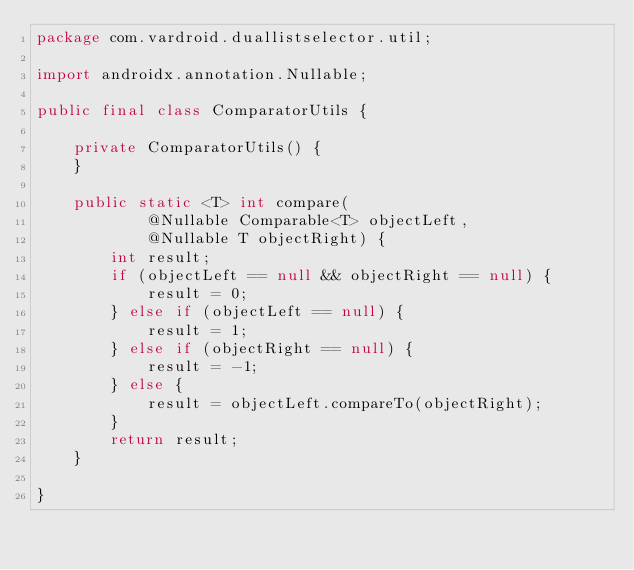<code> <loc_0><loc_0><loc_500><loc_500><_Java_>package com.vardroid.duallistselector.util;

import androidx.annotation.Nullable;

public final class ComparatorUtils {

    private ComparatorUtils() {
    }

    public static <T> int compare(
            @Nullable Comparable<T> objectLeft,
            @Nullable T objectRight) {
        int result;
        if (objectLeft == null && objectRight == null) {
            result = 0;
        } else if (objectLeft == null) {
            result = 1;
        } else if (objectRight == null) {
            result = -1;
        } else {
            result = objectLeft.compareTo(objectRight);
        }
        return result;
    }

}
</code> 